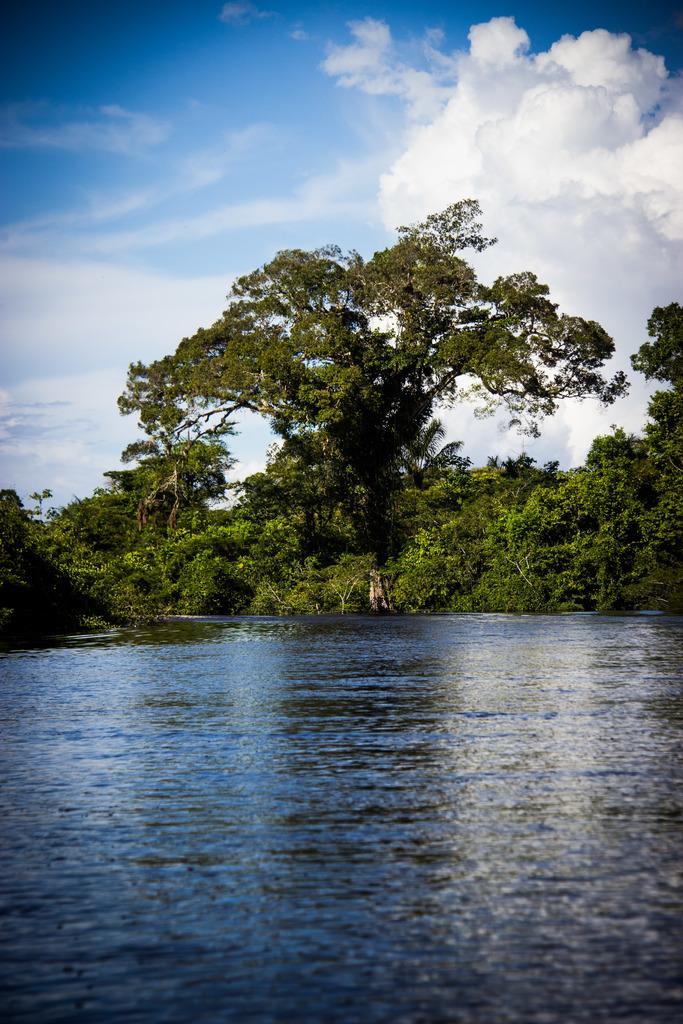Describe this image in one or two sentences. In this image I can see water in the front. In the background I can see number of trees, clouds and the sky. 